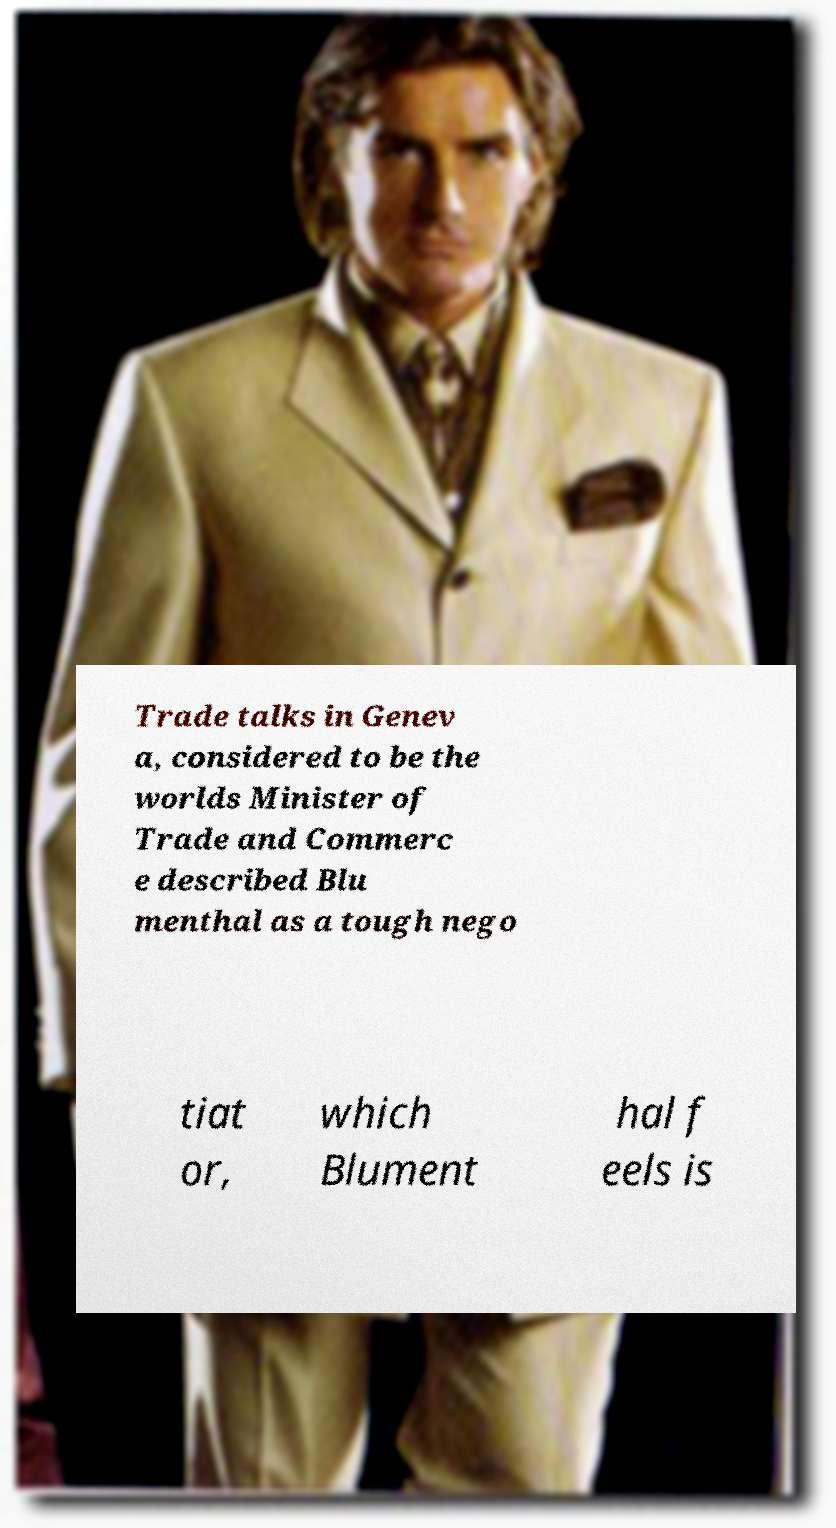Could you assist in decoding the text presented in this image and type it out clearly? Trade talks in Genev a, considered to be the worlds Minister of Trade and Commerc e described Blu menthal as a tough nego tiat or, which Blument hal f eels is 